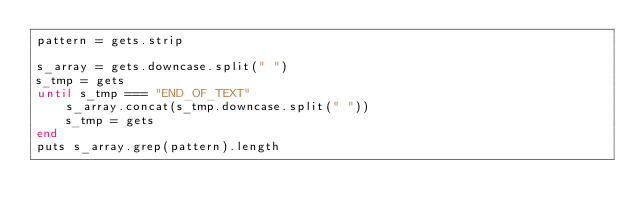<code> <loc_0><loc_0><loc_500><loc_500><_Ruby_>pattern = gets.strip

s_array = gets.downcase.split(" ")
s_tmp = gets
until s_tmp === "END_OF_TEXT"
	s_array.concat(s_tmp.downcase.split(" "))
	s_tmp = gets
end 
puts s_array.grep(pattern).length
</code> 